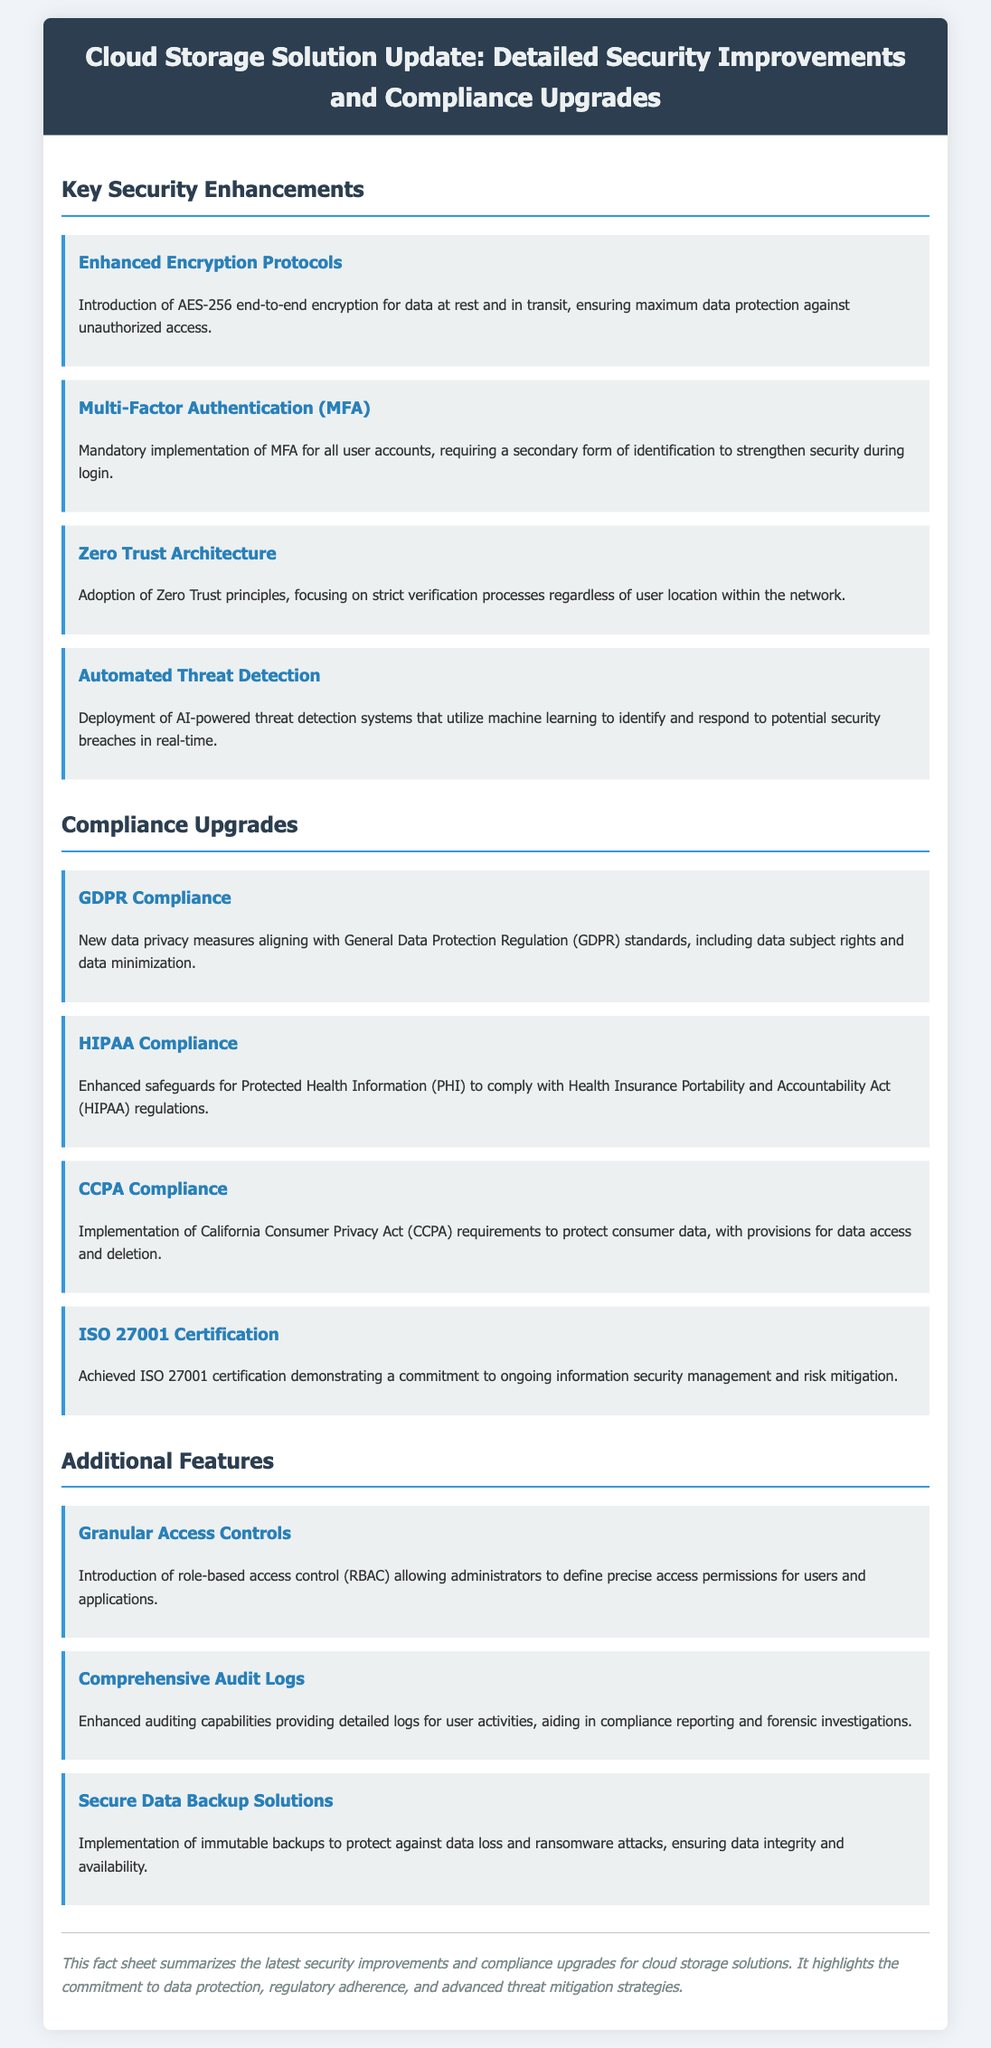What encryption protocol has been introduced? The document mentions the introduction of AES-256 end-to-end encryption for data protection.
Answer: AES-256 What is required for all user accounts? The fact sheet states that Multi-Factor Authentication (MFA) is mandatory for all user accounts.
Answer: MFA Which compliance standard has enhanced safeguards for PHI? The document includes information on HIPAA compliance, which enhances safeguards for Protected Health Information.
Answer: HIPAA What certification demonstrates a commitment to information security management? The document states that ISO 27001 certification has been achieved, showing a commitment to ongoing information security management.
Answer: ISO 27001 What type of architecture is focused on strict verification processes? The document discusses the adoption of Zero Trust Architecture that emphasizes strict verification processes.
Answer: Zero Trust Architecture How are user activities monitored per the additional features? The fact sheet mentions that comprehensive audit logs have enhanced auditing capabilities for monitoring user activities.
Answer: Comprehensive audit logs What kind of backup solutions have been implemented? The document describes the implementation of secure data backup solutions to protect against data loss and ransomware attacks.
Answer: Immutable backups What is a new data privacy measure related to consumer rights? The document states that CCPA compliance has been implemented for the protection of consumer data, including data access and deletion rights.
Answer: CCPA What AI feature is utilized for identifying security breaches? The fact sheet highlights the deployment of AI-powered threat detection systems for identifying potential security breaches.
Answer: AI-powered threat detection 